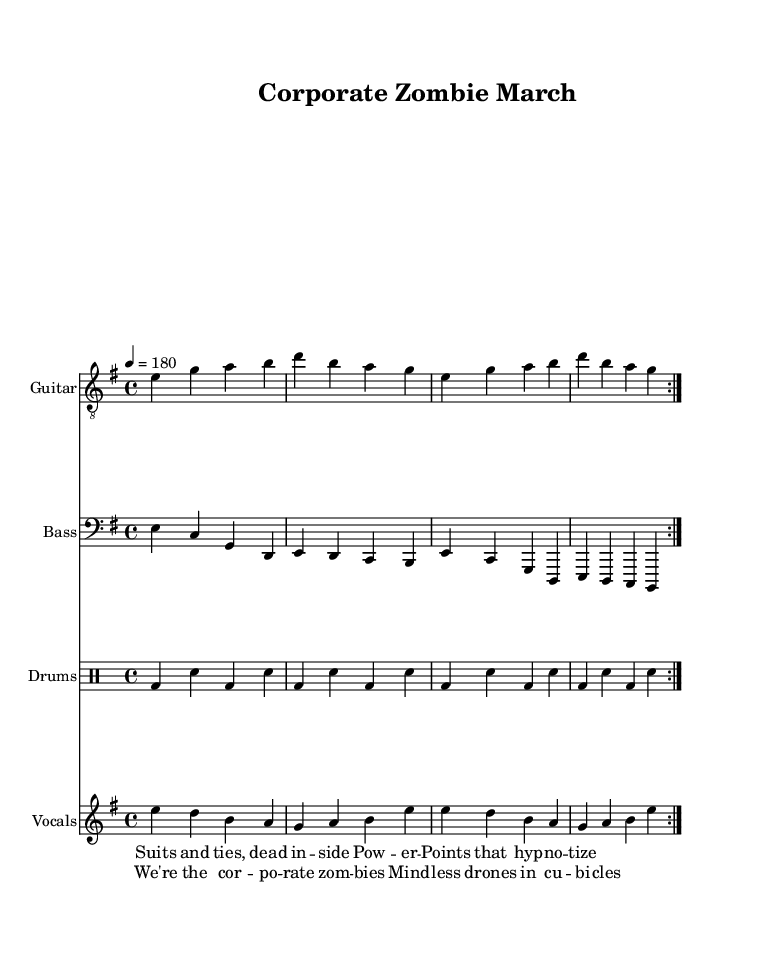What is the key signature of this music? The key signature is indicated at the beginning of the staff. It shows an E minor key signature, which contains one sharp, F♯.
Answer: E minor What is the time signature of the piece? The time signature is found at the beginning of the sheet music and indicates how many beats are in each measure. It is 4/4, meaning there are four beats per measure.
Answer: 4/4 What is the tempo marking for this piece? The tempo marking indicates the speed of the music. In this sheet music, it is marked as 4 beats per minute equals 180.
Answer: 180 How many measures are repeated in the guitar section? The repetition is indicated by the volta markings before the measures. The guitar section has a repeat indication with volta, suggesting two sections are played and repeated.
Answer: Two What lyrical theme does the song represent? The lyrics provide a clear commentary on business culture, using terms like "Corporate Zombies." The overall theme critiques conventional business practices and the mindlessness of office routines.
Answer: Corporate Zombies Which instruments are featured in this piece? The score includes separate sections for guitar, bass, drums, and vocals, demonstrating a typical punk ensemble configuration.
Answer: Guitar, Bass, Drums, Vocals What is the rhythmic pattern of the drums? The drum part consists of a steady beat pattern, alternating between bass and snare hits. This repetitive structure is common in punk music to maintain energy and momentum.
Answer: Alternating bass and snare 